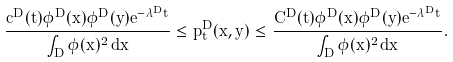Convert formula to latex. <formula><loc_0><loc_0><loc_500><loc_500>\frac { c ^ { D } ( t ) \phi ^ { D } ( x ) \phi ^ { D } ( y ) e ^ { - \lambda ^ { D } t } } { \int _ { D } \phi ( x ) ^ { 2 } \, d x } \leq p _ { t } ^ { D } ( x , y ) \leq \frac { C ^ { D } ( t ) \phi ^ { D } ( x ) \phi ^ { D } ( y ) e ^ { - \lambda ^ { D } t } } { \int _ { D } \phi ( x ) ^ { 2 } \, d x } .</formula> 